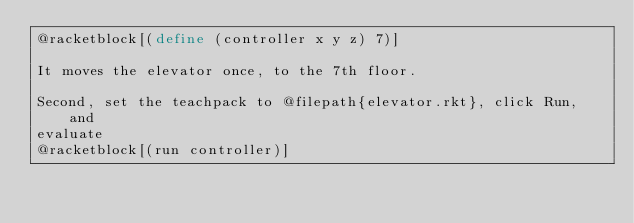<code> <loc_0><loc_0><loc_500><loc_500><_Racket_>@racketblock[(define (controller x y z) 7)]

It moves the elevator once, to the 7th floor.

Second, set the teachpack to @filepath{elevator.rkt}, click Run, and
evaluate
@racketblock[(run controller)]
</code> 